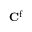<formula> <loc_0><loc_0><loc_500><loc_500>C ^ { f }</formula> 